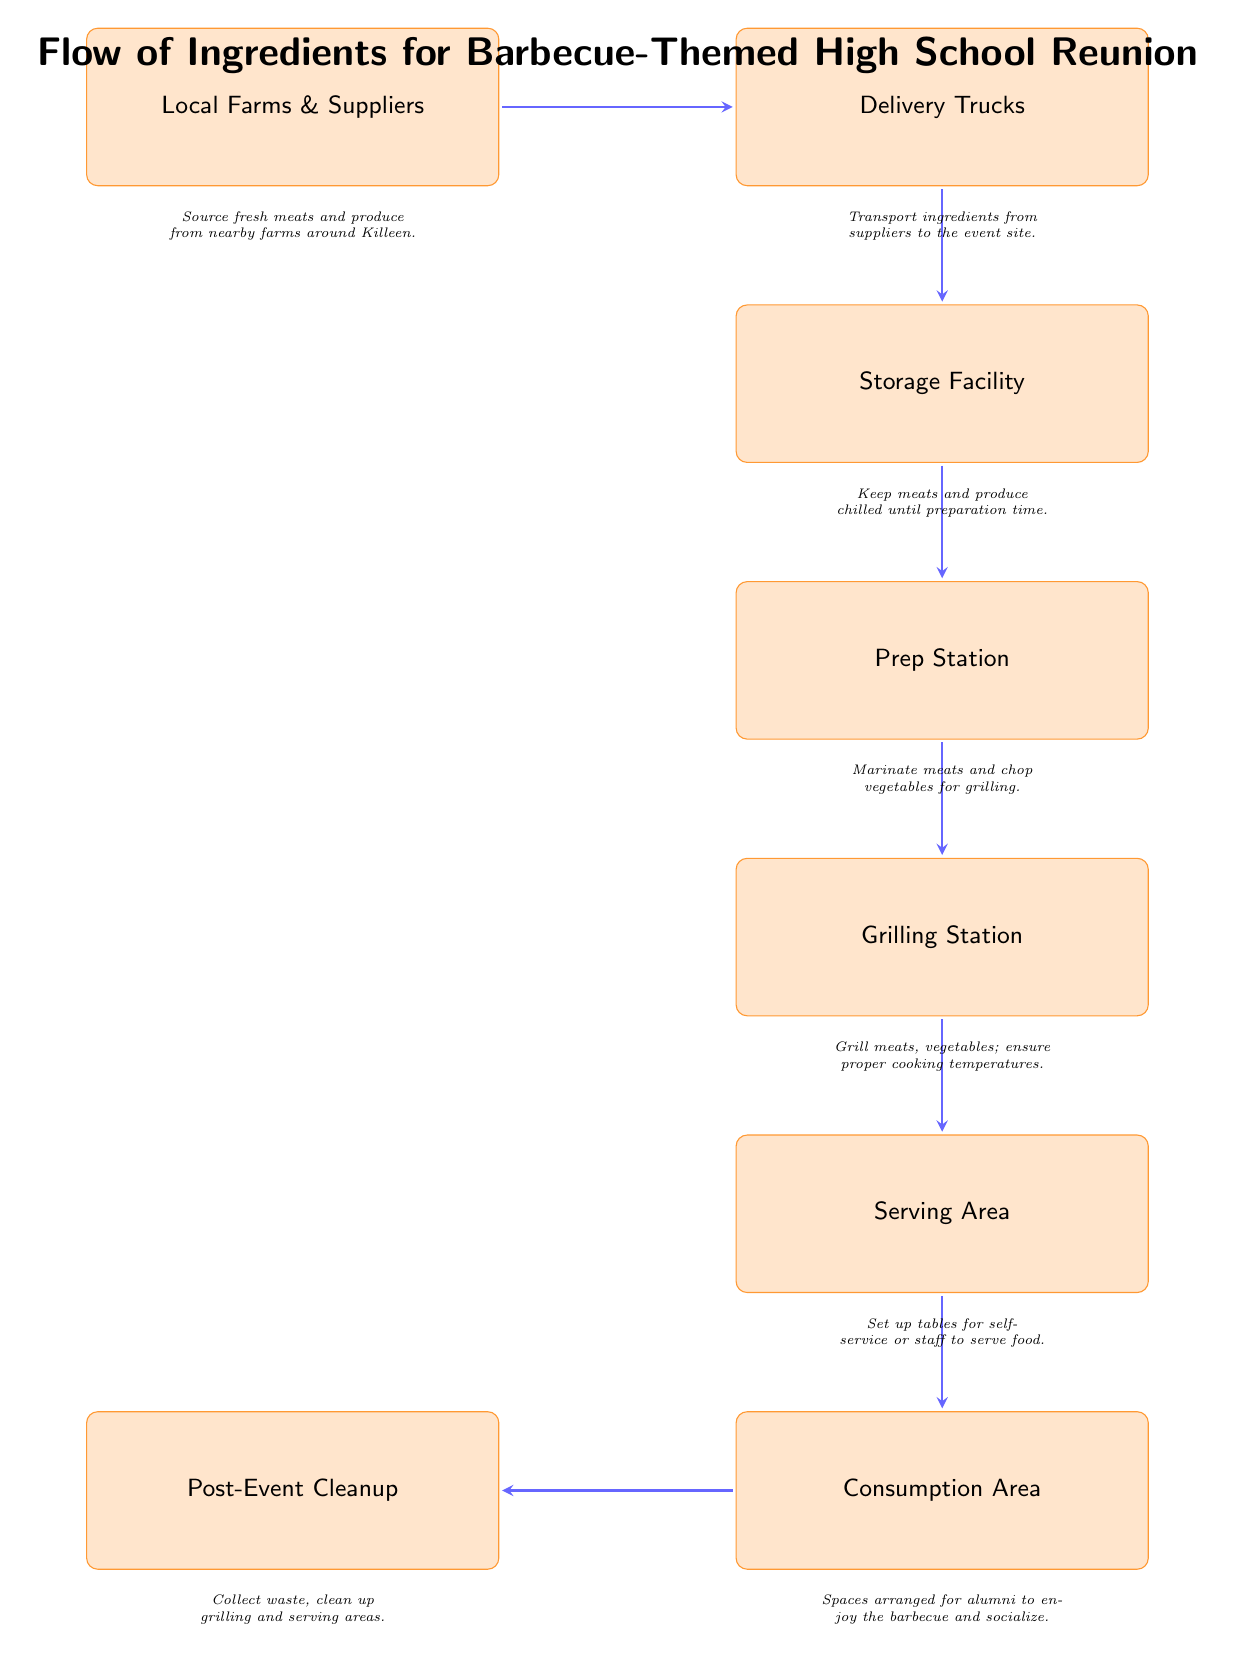What is the first step in the flow of ingredients? The first step is "Local Farms & Suppliers," which is the source of fresh meats and produce. This can be identified as the top node in the diagram, indicating the starting point of the flow.
Answer: Local Farms & Suppliers How many nodes are in the diagram? To find the number of nodes, count each distinct box representing a step in the flow. The diagram shows eight boxes arranged in a specific order, representing the complete flow.
Answer: 8 What happens after the Delivery Trucks? After the Delivery Trucks, the next step is the "Storage Facility." This can be determined by following the flow from the Delivery Trucks box down to the next connected box in the diagram.
Answer: Storage Facility Which node comes before the Serving Area? The node that comes before the Serving Area is the "Grilling Station." This is determined by the downward flow in the diagram leading to the Serving Area, which lists the Grilling Station immediately above it.
Answer: Grilling Station What is the final step of the ingredient flow? The final step of the ingredient flow is the "Post-Event Cleanup." This is indicated as the last box in the flow, following the Consumption Area as depicted in the diagram.
Answer: Post-Event Cleanup What is the purpose of the Prep Station? The purpose of the Prep Station is to "Marinate meats and chop vegetables for grilling." This is specified in the description underneath the Prep Station box, indicating its function within the flow.
Answer: Marinate meats and chop vegetables How many arrows indicate the flow between the nodes? Count the arrows connecting the boxes in the diagram to determine the flow. There are seven arrows, each representing a transfer of ingredients or a step in the process between nodes.
Answer: 7 Which node is left of the Consumption Area? The node to the left of the Consumption Area is the "Serving Area." This relationship can be established by observing the relative positions of the nodes within the diagram's layout.
Answer: Serving Area 